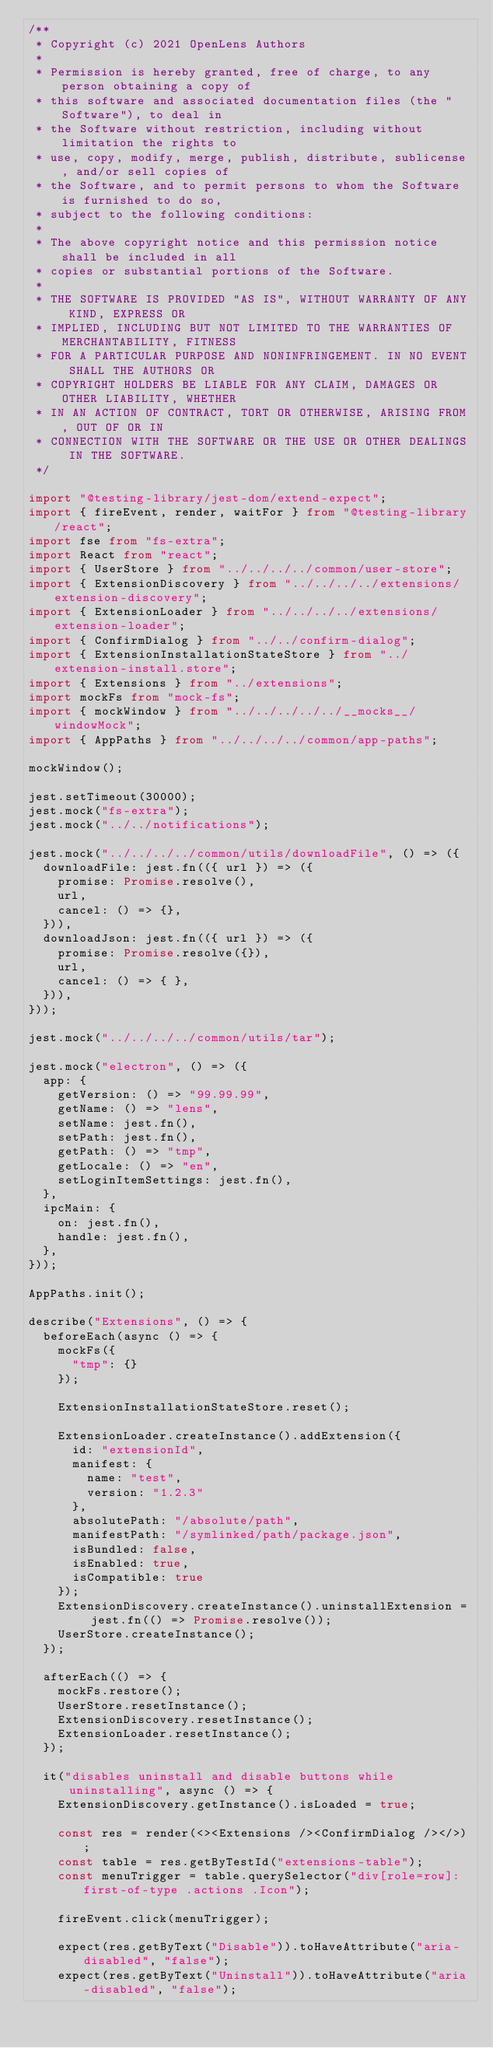<code> <loc_0><loc_0><loc_500><loc_500><_TypeScript_>/**
 * Copyright (c) 2021 OpenLens Authors
 *
 * Permission is hereby granted, free of charge, to any person obtaining a copy of
 * this software and associated documentation files (the "Software"), to deal in
 * the Software without restriction, including without limitation the rights to
 * use, copy, modify, merge, publish, distribute, sublicense, and/or sell copies of
 * the Software, and to permit persons to whom the Software is furnished to do so,
 * subject to the following conditions:
 *
 * The above copyright notice and this permission notice shall be included in all
 * copies or substantial portions of the Software.
 *
 * THE SOFTWARE IS PROVIDED "AS IS", WITHOUT WARRANTY OF ANY KIND, EXPRESS OR
 * IMPLIED, INCLUDING BUT NOT LIMITED TO THE WARRANTIES OF MERCHANTABILITY, FITNESS
 * FOR A PARTICULAR PURPOSE AND NONINFRINGEMENT. IN NO EVENT SHALL THE AUTHORS OR
 * COPYRIGHT HOLDERS BE LIABLE FOR ANY CLAIM, DAMAGES OR OTHER LIABILITY, WHETHER
 * IN AN ACTION OF CONTRACT, TORT OR OTHERWISE, ARISING FROM, OUT OF OR IN
 * CONNECTION WITH THE SOFTWARE OR THE USE OR OTHER DEALINGS IN THE SOFTWARE.
 */

import "@testing-library/jest-dom/extend-expect";
import { fireEvent, render, waitFor } from "@testing-library/react";
import fse from "fs-extra";
import React from "react";
import { UserStore } from "../../../../common/user-store";
import { ExtensionDiscovery } from "../../../../extensions/extension-discovery";
import { ExtensionLoader } from "../../../../extensions/extension-loader";
import { ConfirmDialog } from "../../confirm-dialog";
import { ExtensionInstallationStateStore } from "../extension-install.store";
import { Extensions } from "../extensions";
import mockFs from "mock-fs";
import { mockWindow } from "../../../../../__mocks__/windowMock";
import { AppPaths } from "../../../../common/app-paths";

mockWindow();

jest.setTimeout(30000);
jest.mock("fs-extra");
jest.mock("../../notifications");

jest.mock("../../../../common/utils/downloadFile", () => ({
  downloadFile: jest.fn(({ url }) => ({
    promise: Promise.resolve(),
    url,
    cancel: () => {},
  })),
  downloadJson: jest.fn(({ url }) => ({
    promise: Promise.resolve({}),
    url,
    cancel: () => { },
  })),
}));

jest.mock("../../../../common/utils/tar");

jest.mock("electron", () => ({
  app: {
    getVersion: () => "99.99.99",
    getName: () => "lens",
    setName: jest.fn(),
    setPath: jest.fn(),
    getPath: () => "tmp",
    getLocale: () => "en",
    setLoginItemSettings: jest.fn(),
  },
  ipcMain: {
    on: jest.fn(),
    handle: jest.fn(),
  },
}));

AppPaths.init();

describe("Extensions", () => {
  beforeEach(async () => {
    mockFs({
      "tmp": {}
    });

    ExtensionInstallationStateStore.reset();

    ExtensionLoader.createInstance().addExtension({
      id: "extensionId",
      manifest: {
        name: "test",
        version: "1.2.3"
      },
      absolutePath: "/absolute/path",
      manifestPath: "/symlinked/path/package.json",
      isBundled: false,
      isEnabled: true,
      isCompatible: true
    });
    ExtensionDiscovery.createInstance().uninstallExtension = jest.fn(() => Promise.resolve());
    UserStore.createInstance();
  });

  afterEach(() => {
    mockFs.restore();
    UserStore.resetInstance();
    ExtensionDiscovery.resetInstance();
    ExtensionLoader.resetInstance();
  });

  it("disables uninstall and disable buttons while uninstalling", async () => {
    ExtensionDiscovery.getInstance().isLoaded = true;

    const res = render(<><Extensions /><ConfirmDialog /></>);
    const table = res.getByTestId("extensions-table");
    const menuTrigger = table.querySelector("div[role=row]:first-of-type .actions .Icon");

    fireEvent.click(menuTrigger);

    expect(res.getByText("Disable")).toHaveAttribute("aria-disabled", "false");
    expect(res.getByText("Uninstall")).toHaveAttribute("aria-disabled", "false");
</code> 